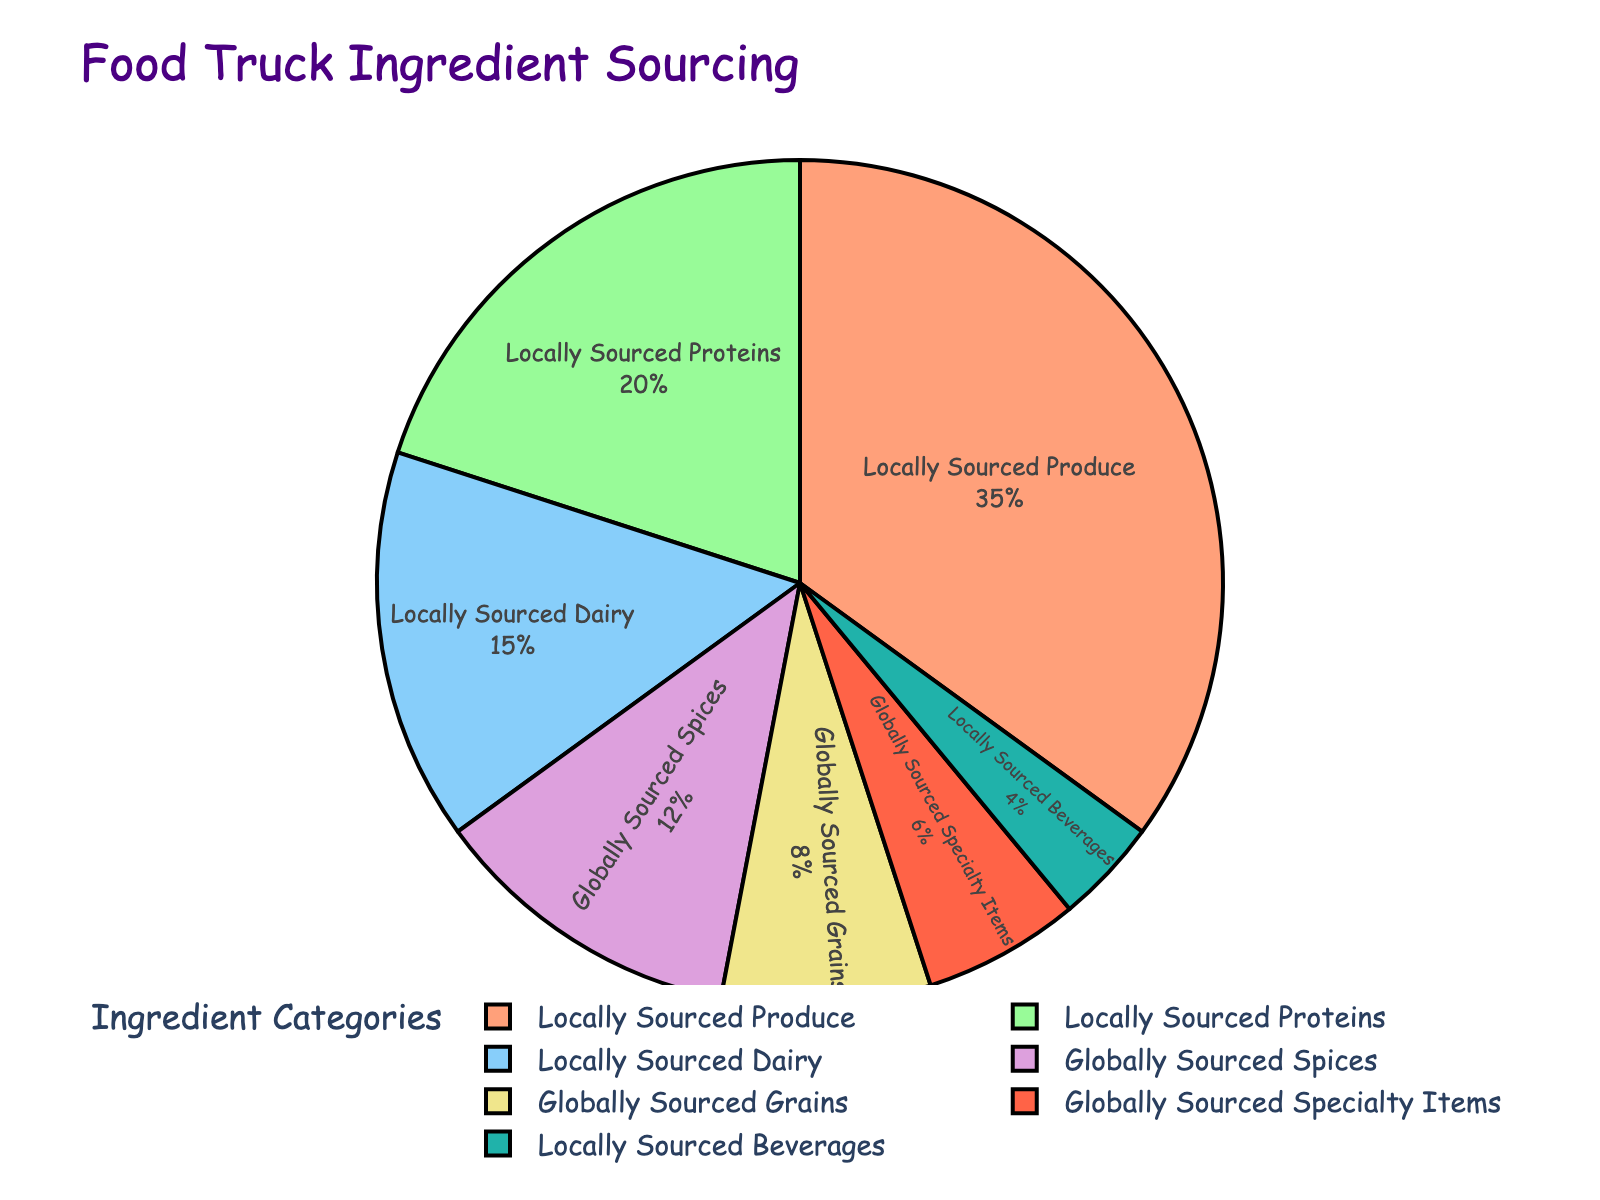What's the total percentage of ingredients sourced locally? Add up the percentages of all categories labeled as "Locally Sourced". That includes Produce (35), Proteins (20), Dairy (15), and Beverages (4). So the total is 35 + 20 + 15 + 4.
Answer: 74 Which category has the highest percentage? To determine the category with the highest percentage, look at each segment of the pie chart and identify the category with the largest segment. "Locally Sourced Produce" is the biggest segment.
Answer: Locally Sourced Produce How do globally sourced items compare to locally sourced items in total percentage? Add up the percentages of "Globally Sourced" categories: Spices (12), Grains (8), and Specialty Items (6). Then, compare this sum to the total percentage of locally sourced items calculated earlier (74).
Answer: Globally Sourced: 26, Locally Sourced: 74 Which category has the smallest percentage and what is it? Identify the smallest segment in the pie chart, which represents the category with the lowest percentage.
Answer: Locally Sourced Beverages: 4% What is the visual difference between the locally sourced and globally sourced segments in terms of color? Describe the general color scheme used for local vs. global categories. Locally sourced categories are in colors like salmon, light green, sky blue, and teal; globally sourced categories are in purple, yellow, and red.
Answer: Locals: warmer and cooler shades (salmon, green, blue, teal), Globals: vibrant shades (purple, yellow, red) Which categories make up more than 50% together? Identify the individual categories and sum their percentages until the cumulative total exceeds 50%. Locally Sourced Produce (35) + Proteins (20) reach 55%.
Answer: Locally Sourced Produce and Proteins What is the difference in percentage between Locally Sourced Produce and Globally Sourced Spices? Subtract the percentage of Globally Sourced Spices (12) from that of Locally Sourced Produce (35).
Answer: 23 Is the combined percentage of Globally Sourced Grains and Specialty Items greater than Locally Sourced Dairy? Add the percentages of Globally Sourced Grains (8) and Specialty Items (6), then compare the sum (14) to Locally Sourced Dairy (15).
Answer: No How many categories are represented in the pie chart? Count the number of distinct segments/categories in the pie chart.
Answer: 7 